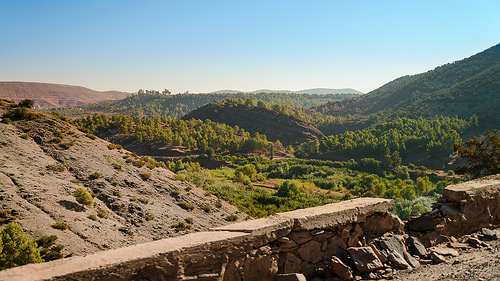<image>
Is there a bridge next to the grass? No. The bridge is not positioned next to the grass. They are located in different areas of the scene. 